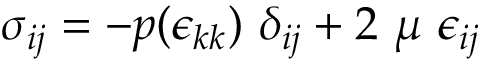<formula> <loc_0><loc_0><loc_500><loc_500>\sigma _ { i j } = - p ( \epsilon _ { k k } ) \delta _ { i j } + 2 \mu \epsilon _ { i j }</formula> 